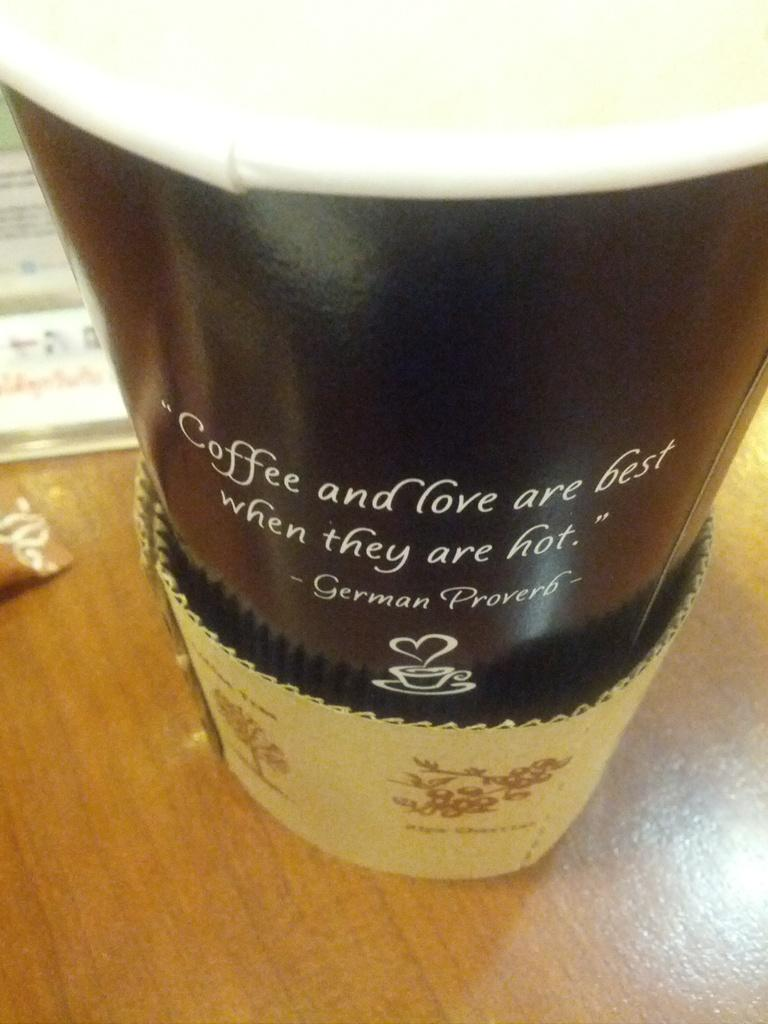What is placed on the wooden surface in the image? There is a glass on a wooden surface. Can you describe any other objects present in the image? Unfortunately, the provided facts only mention that there are some objects present in the image, but their specific details are not given. What type of comb is the girl using to fix her veil in the image? There is no girl or veil present in the image; it only features a glass on a wooden surface. 